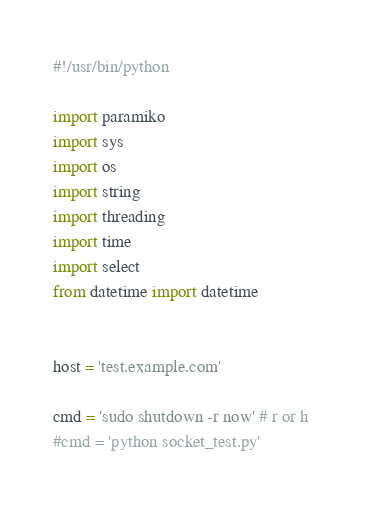Convert code to text. <code><loc_0><loc_0><loc_500><loc_500><_Python_>#!/usr/bin/python 

import paramiko 
import sys 
import os
import string 
import threading
import time
import select
from datetime import datetime


host = 'test.example.com'

cmd = 'sudo shutdown -r now' # r or h 
#cmd = 'python socket_test.py'
 </code> 